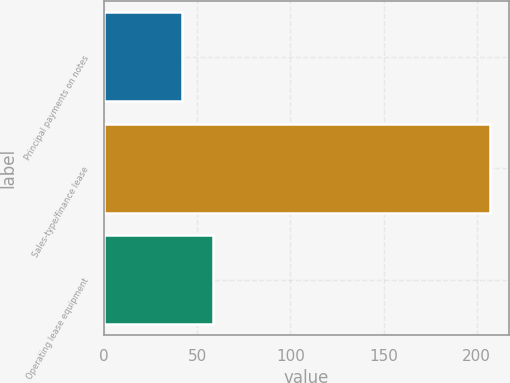<chart> <loc_0><loc_0><loc_500><loc_500><bar_chart><fcel>Principal payments on notes<fcel>Sales-type/finance lease<fcel>Operating lease equipment<nl><fcel>42<fcel>207<fcel>58.5<nl></chart> 